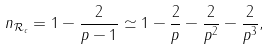Convert formula to latex. <formula><loc_0><loc_0><loc_500><loc_500>n _ { \mathcal { R } _ { c } } = 1 - \frac { 2 } { p - 1 } \simeq 1 - \frac { 2 } { p } - \frac { 2 } { p ^ { 2 } } - \frac { 2 } { p ^ { 3 } } ,</formula> 